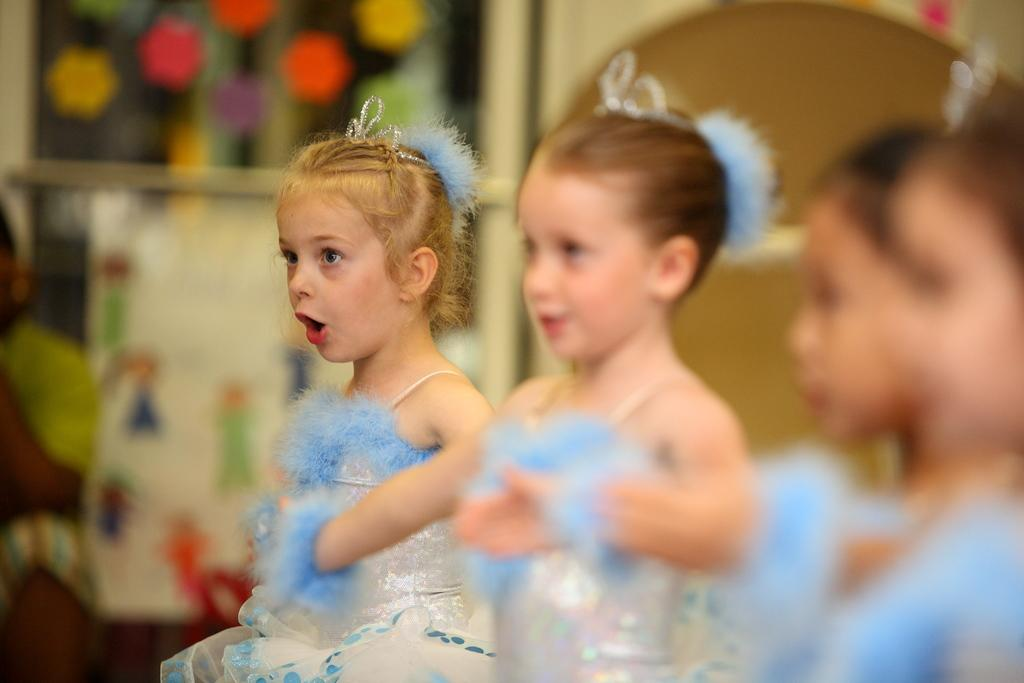What is the main subject of the image? The main subject of the image is kids standing. Can you describe the background of the image? The background of the image is blurred. How many cats are sitting on the table in the image? There are no cats present in the image; it only features kids standing. What type of meal is being prepared in the image? There is no meal preparation visible in the image; it only shows kids standing with a blurred background. 